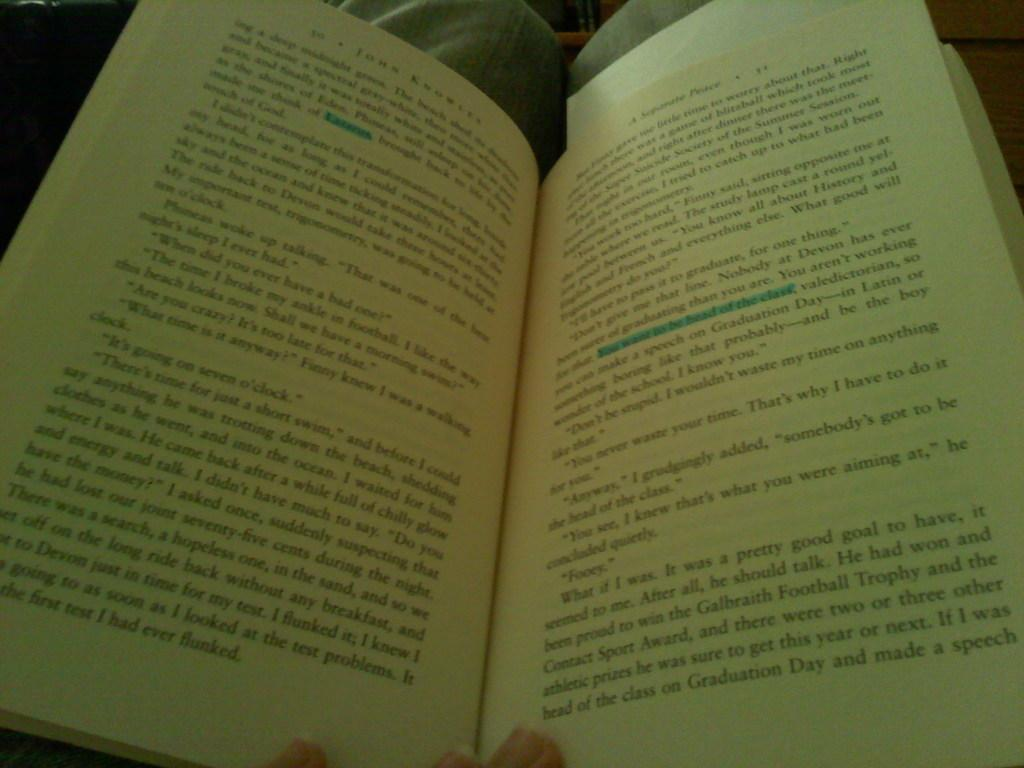<image>
Describe the image concisely. A book is open, the last line talks about graduation day. 